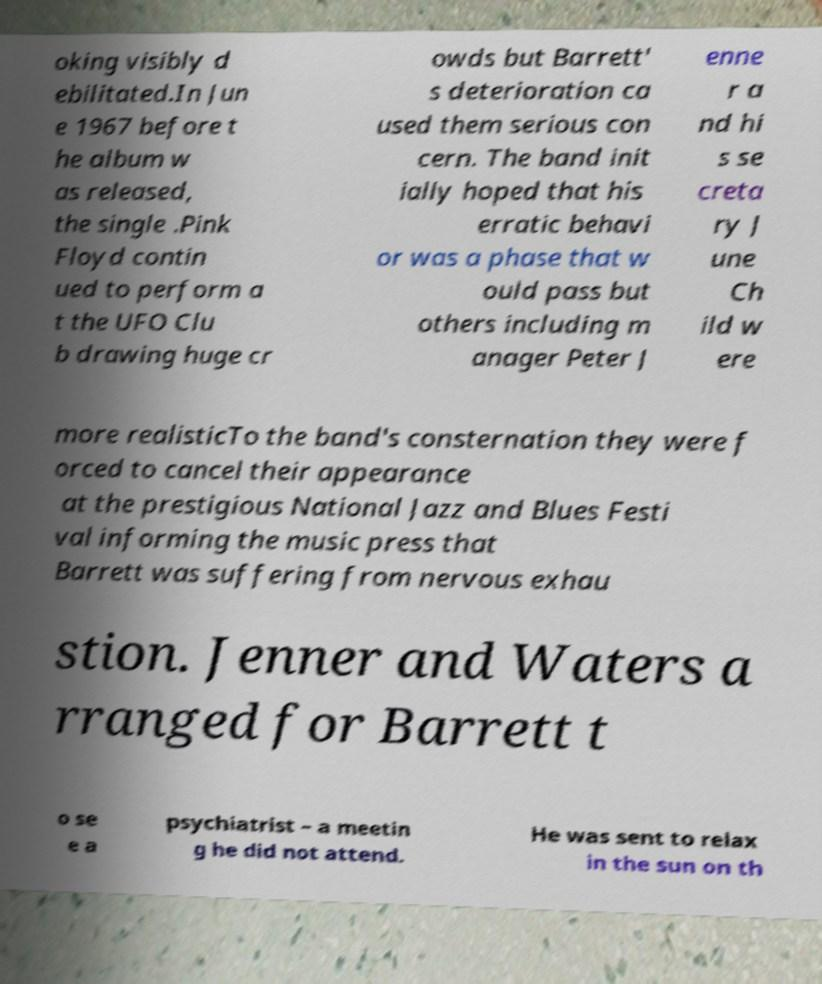Could you assist in decoding the text presented in this image and type it out clearly? oking visibly d ebilitated.In Jun e 1967 before t he album w as released, the single .Pink Floyd contin ued to perform a t the UFO Clu b drawing huge cr owds but Barrett' s deterioration ca used them serious con cern. The band init ially hoped that his erratic behavi or was a phase that w ould pass but others including m anager Peter J enne r a nd hi s se creta ry J une Ch ild w ere more realisticTo the band's consternation they were f orced to cancel their appearance at the prestigious National Jazz and Blues Festi val informing the music press that Barrett was suffering from nervous exhau stion. Jenner and Waters a rranged for Barrett t o se e a psychiatrist – a meetin g he did not attend. He was sent to relax in the sun on th 